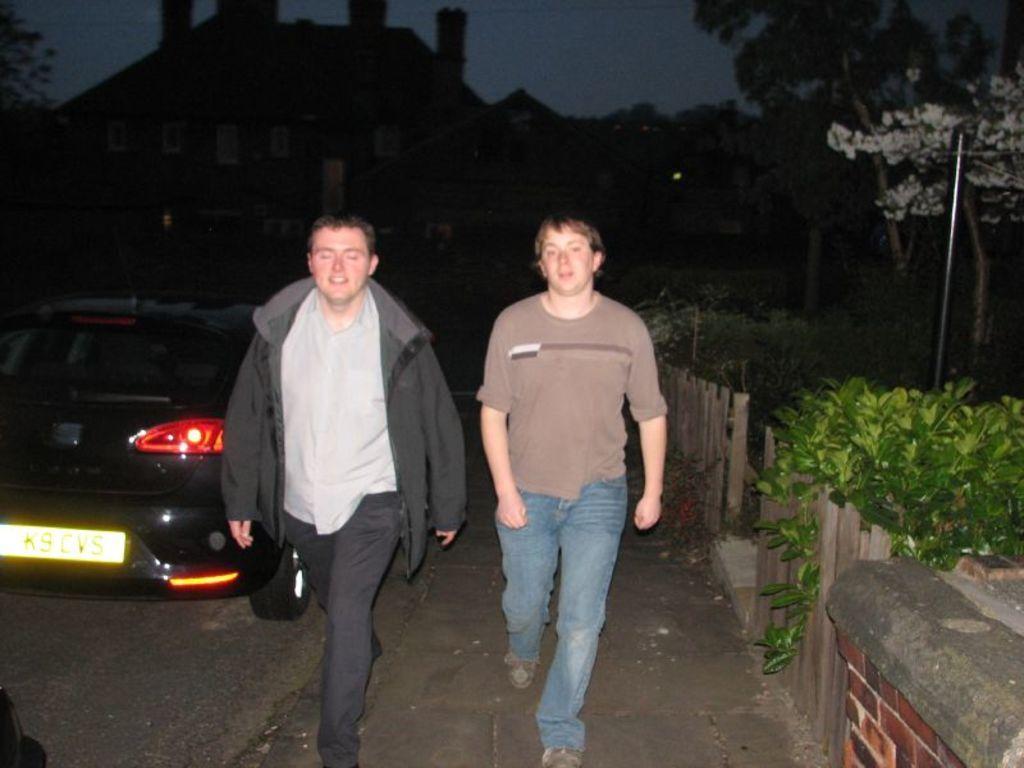Describe this image in one or two sentences. In this image I can see two men are standing. I can see one of them is wearing jacket. In background I can see plants, trees, a vehicle, a building and here I can see something is written. I can also see this image is little bit in dark from background. 